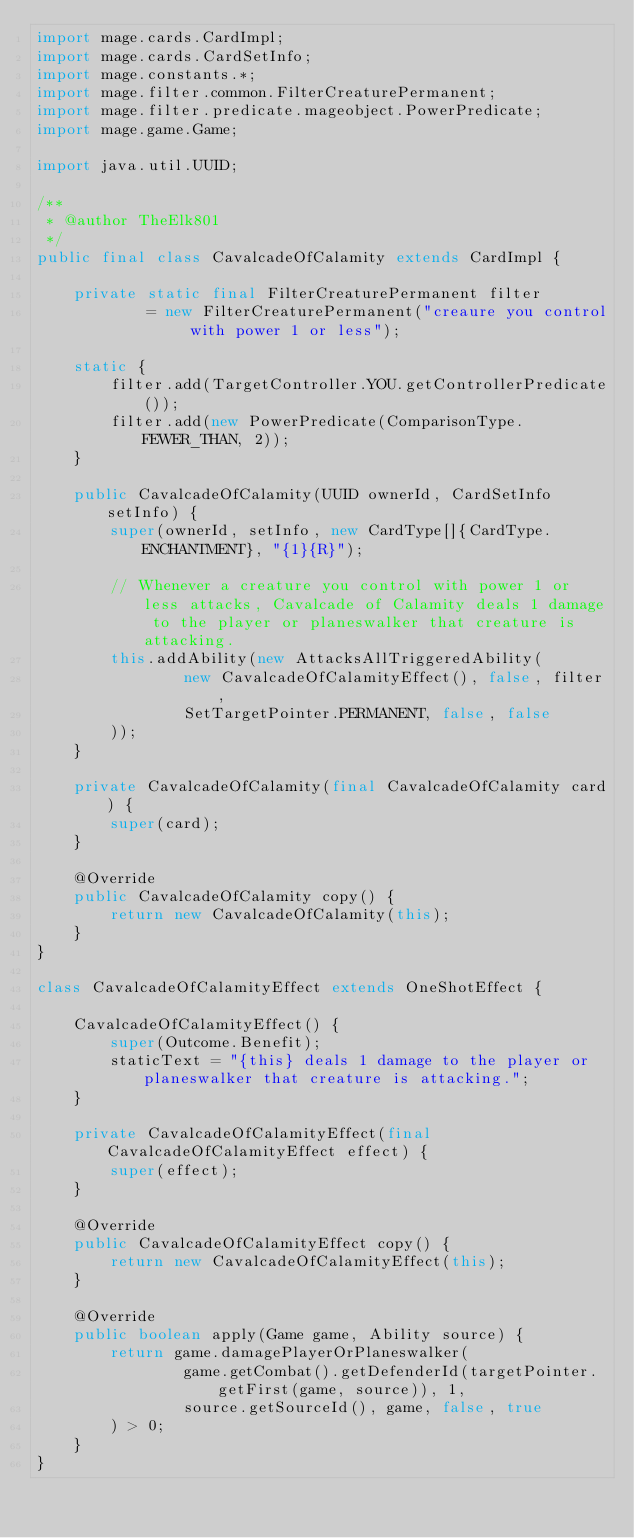Convert code to text. <code><loc_0><loc_0><loc_500><loc_500><_Java_>import mage.cards.CardImpl;
import mage.cards.CardSetInfo;
import mage.constants.*;
import mage.filter.common.FilterCreaturePermanent;
import mage.filter.predicate.mageobject.PowerPredicate;
import mage.game.Game;

import java.util.UUID;

/**
 * @author TheElk801
 */
public final class CavalcadeOfCalamity extends CardImpl {

    private static final FilterCreaturePermanent filter
            = new FilterCreaturePermanent("creaure you control with power 1 or less");

    static {
        filter.add(TargetController.YOU.getControllerPredicate());
        filter.add(new PowerPredicate(ComparisonType.FEWER_THAN, 2));
    }

    public CavalcadeOfCalamity(UUID ownerId, CardSetInfo setInfo) {
        super(ownerId, setInfo, new CardType[]{CardType.ENCHANTMENT}, "{1}{R}");

        // Whenever a creature you control with power 1 or less attacks, Cavalcade of Calamity deals 1 damage to the player or planeswalker that creature is attacking.
        this.addAbility(new AttacksAllTriggeredAbility(
                new CavalcadeOfCalamityEffect(), false, filter,
                SetTargetPointer.PERMANENT, false, false
        ));
    }

    private CavalcadeOfCalamity(final CavalcadeOfCalamity card) {
        super(card);
    }

    @Override
    public CavalcadeOfCalamity copy() {
        return new CavalcadeOfCalamity(this);
    }
}

class CavalcadeOfCalamityEffect extends OneShotEffect {

    CavalcadeOfCalamityEffect() {
        super(Outcome.Benefit);
        staticText = "{this} deals 1 damage to the player or planeswalker that creature is attacking.";
    }

    private CavalcadeOfCalamityEffect(final CavalcadeOfCalamityEffect effect) {
        super(effect);
    }

    @Override
    public CavalcadeOfCalamityEffect copy() {
        return new CavalcadeOfCalamityEffect(this);
    }

    @Override
    public boolean apply(Game game, Ability source) {
        return game.damagePlayerOrPlaneswalker(
                game.getCombat().getDefenderId(targetPointer.getFirst(game, source)), 1,
                source.getSourceId(), game, false, true
        ) > 0;
    }
}</code> 